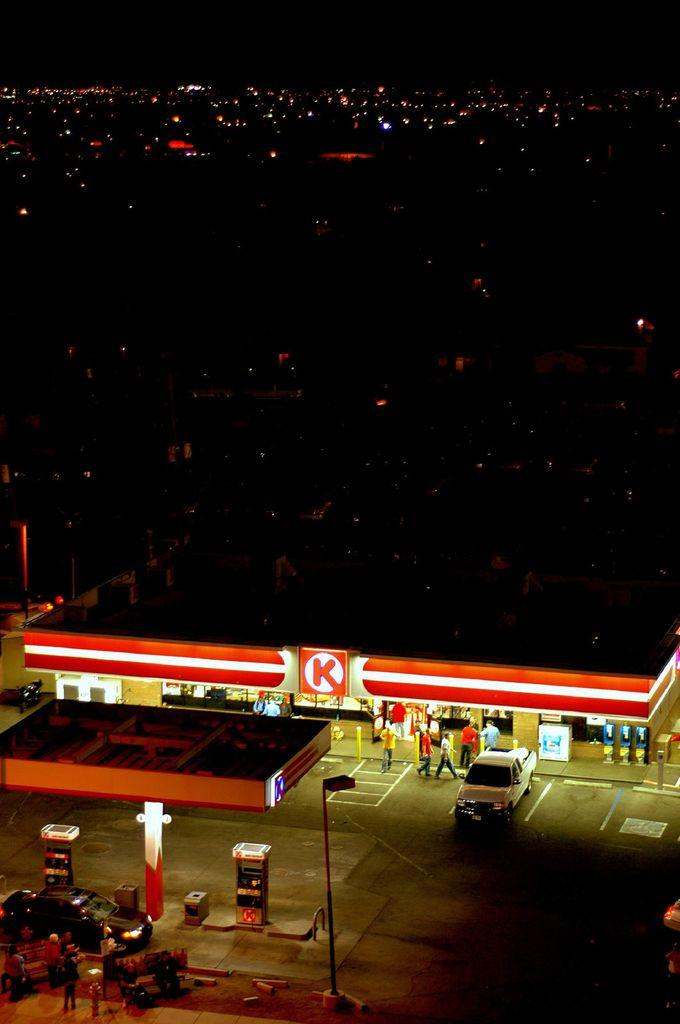<image>
Write a terse but informative summary of the picture. a night scene with background city lights and a big K in the foreground 